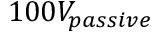Convert formula to latex. <formula><loc_0><loc_0><loc_500><loc_500>1 0 0 V _ { p a s s i v e }</formula> 